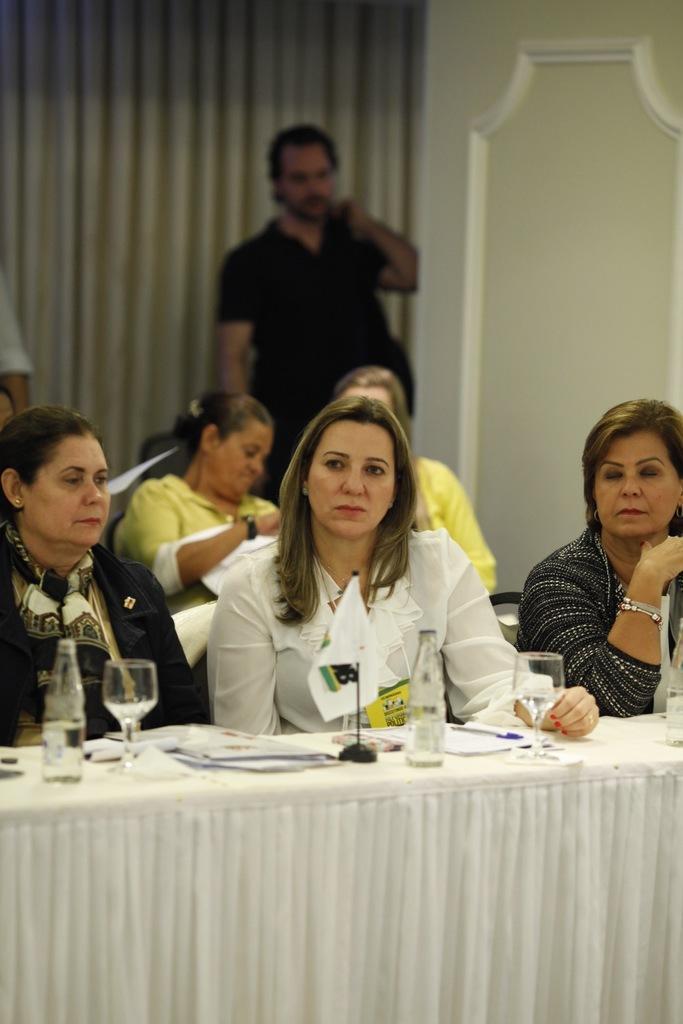Could you give a brief overview of what you see in this image? There is a group of people. They are sitting on a chair. There is a glass,bottle,paper and pen on a table. We can see the background there is a curtain and man. 